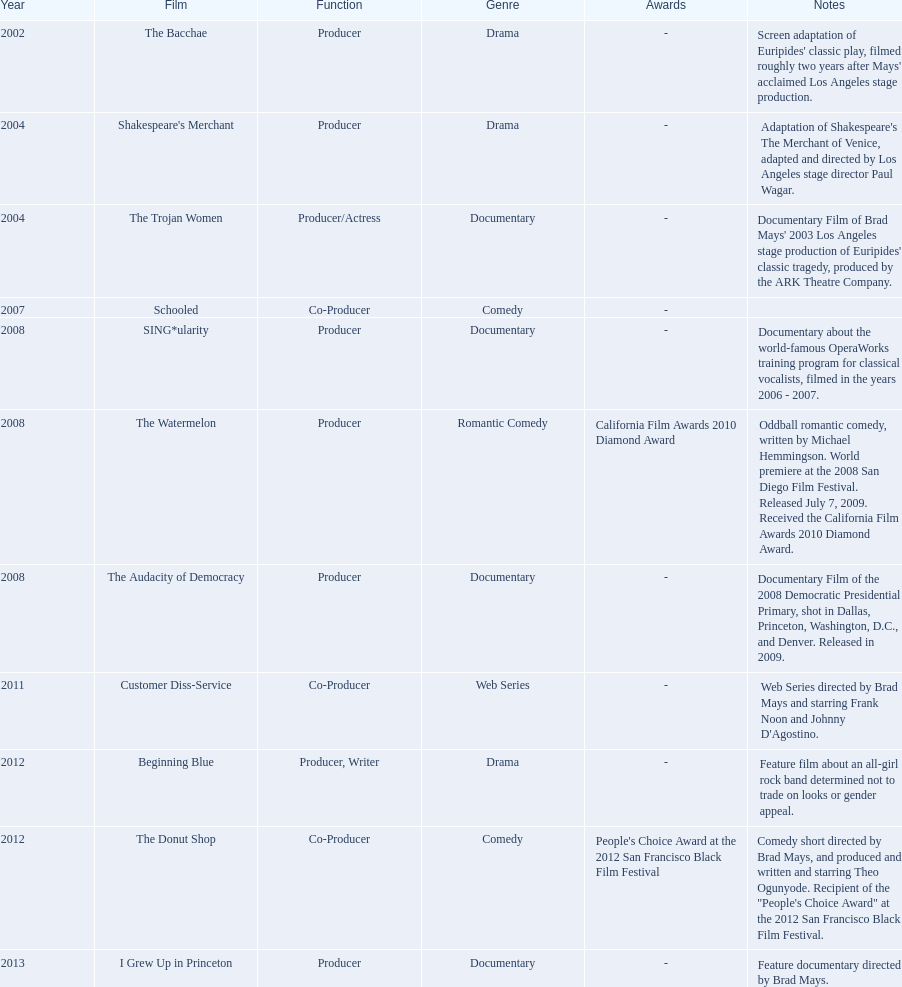Who was the first producer that made the film sing*ularity? Lorenda Starfelt. 